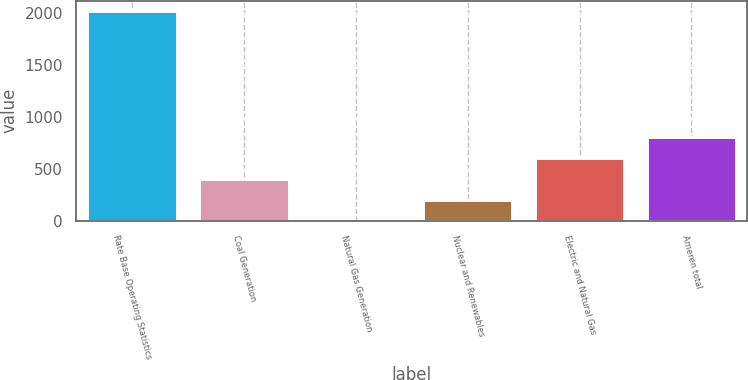Convert chart to OTSL. <chart><loc_0><loc_0><loc_500><loc_500><bar_chart><fcel>Rate Base Operating Statistics<fcel>Coal Generation<fcel>Natural Gas Generation<fcel>Nuclear and Renewables<fcel>Electric and Natural Gas<fcel>Ameren total<nl><fcel>2016<fcel>403.52<fcel>0.4<fcel>201.96<fcel>605.08<fcel>806.64<nl></chart> 